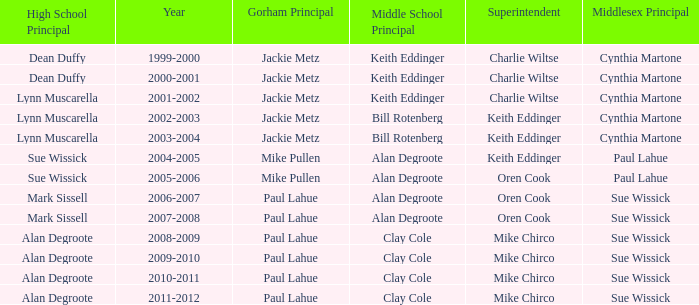Who were the middle school head(s) in 2010-2011? Clay Cole. 